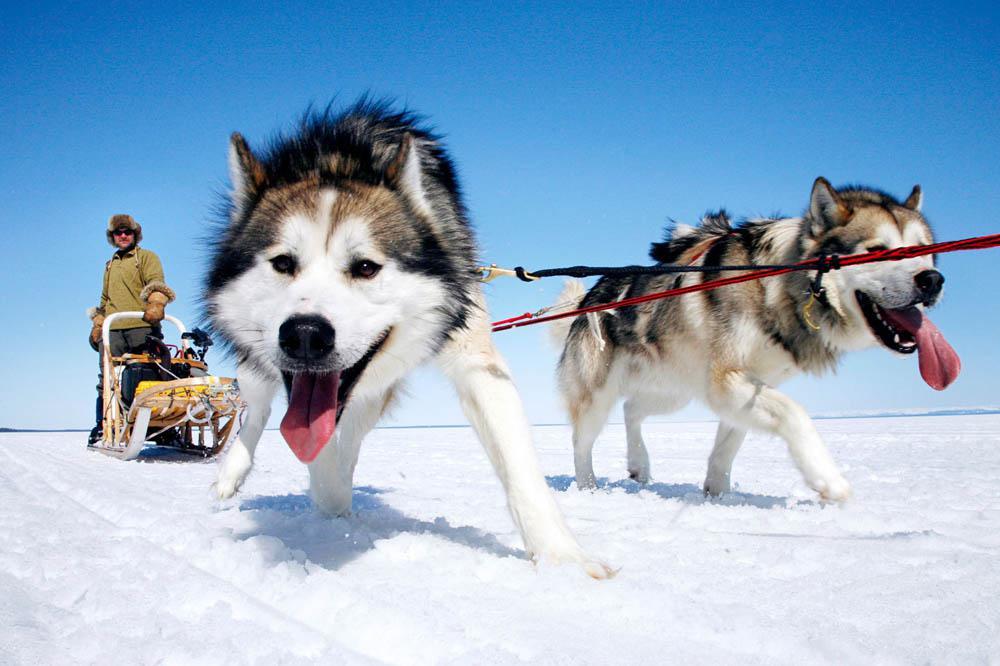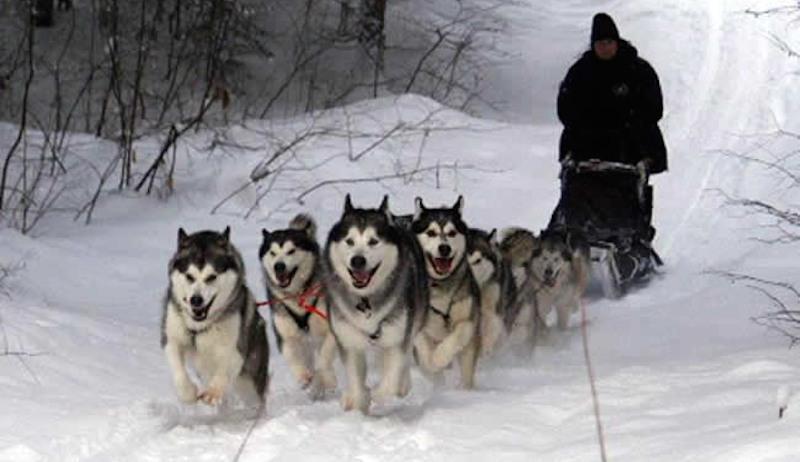The first image is the image on the left, the second image is the image on the right. Examine the images to the left and right. Is the description "One dog team with a sled driver standing in back is headed forward and to the left down snowy ground with no bystanders." accurate? Answer yes or no. Yes. The first image is the image on the left, the second image is the image on the right. For the images shown, is this caption "There are only two dogs pulling one of the sleds." true? Answer yes or no. Yes. 